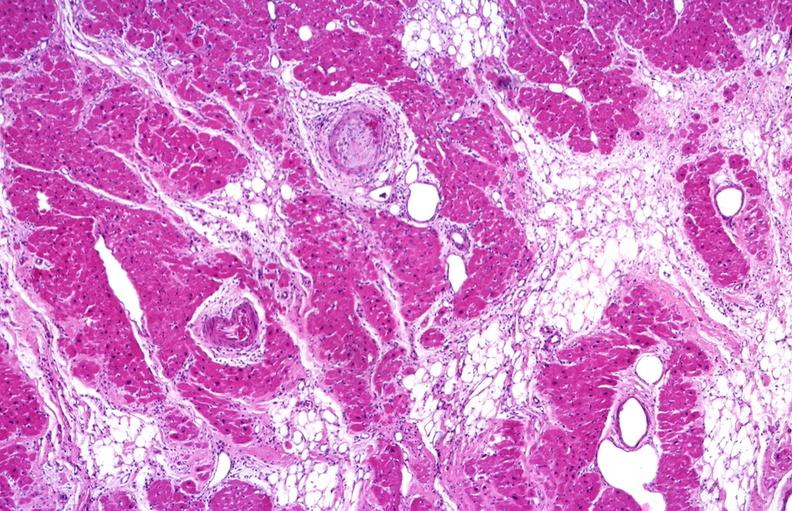what is present?
Answer the question using a single word or phrase. Cardiovascular 